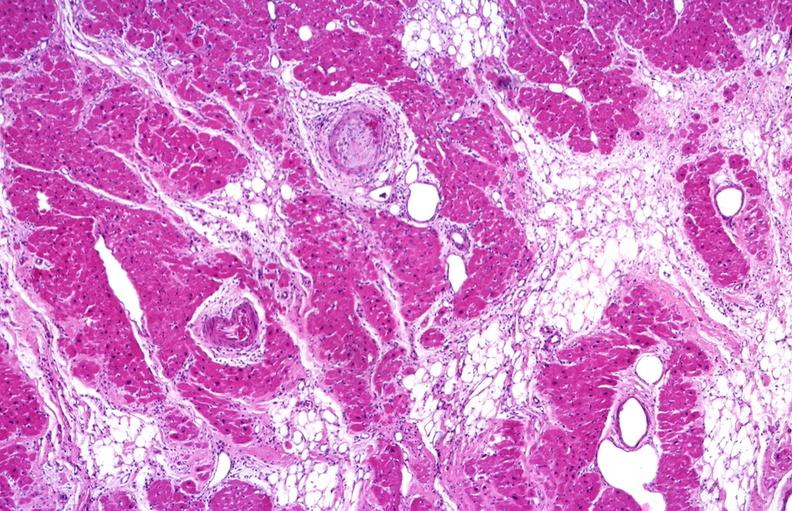what is present?
Answer the question using a single word or phrase. Cardiovascular 